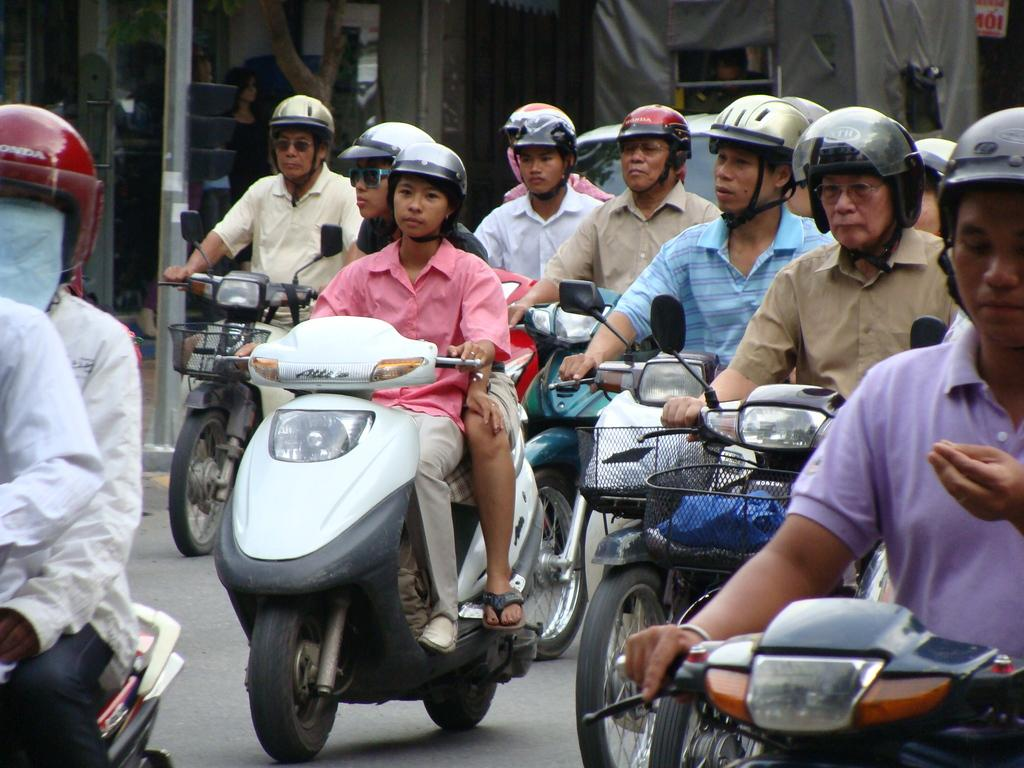Where is the image taken? The image is taken on a road. What are the people doing in the image? People are traveling on their bikes in the image. What safety precaution are the people taking while riding their bikes? The people are wearing helmets in the image. What type of banana is being used as a pail in the image? There is no banana or pail present in the image; people are riding bikes while wearing helmets. 